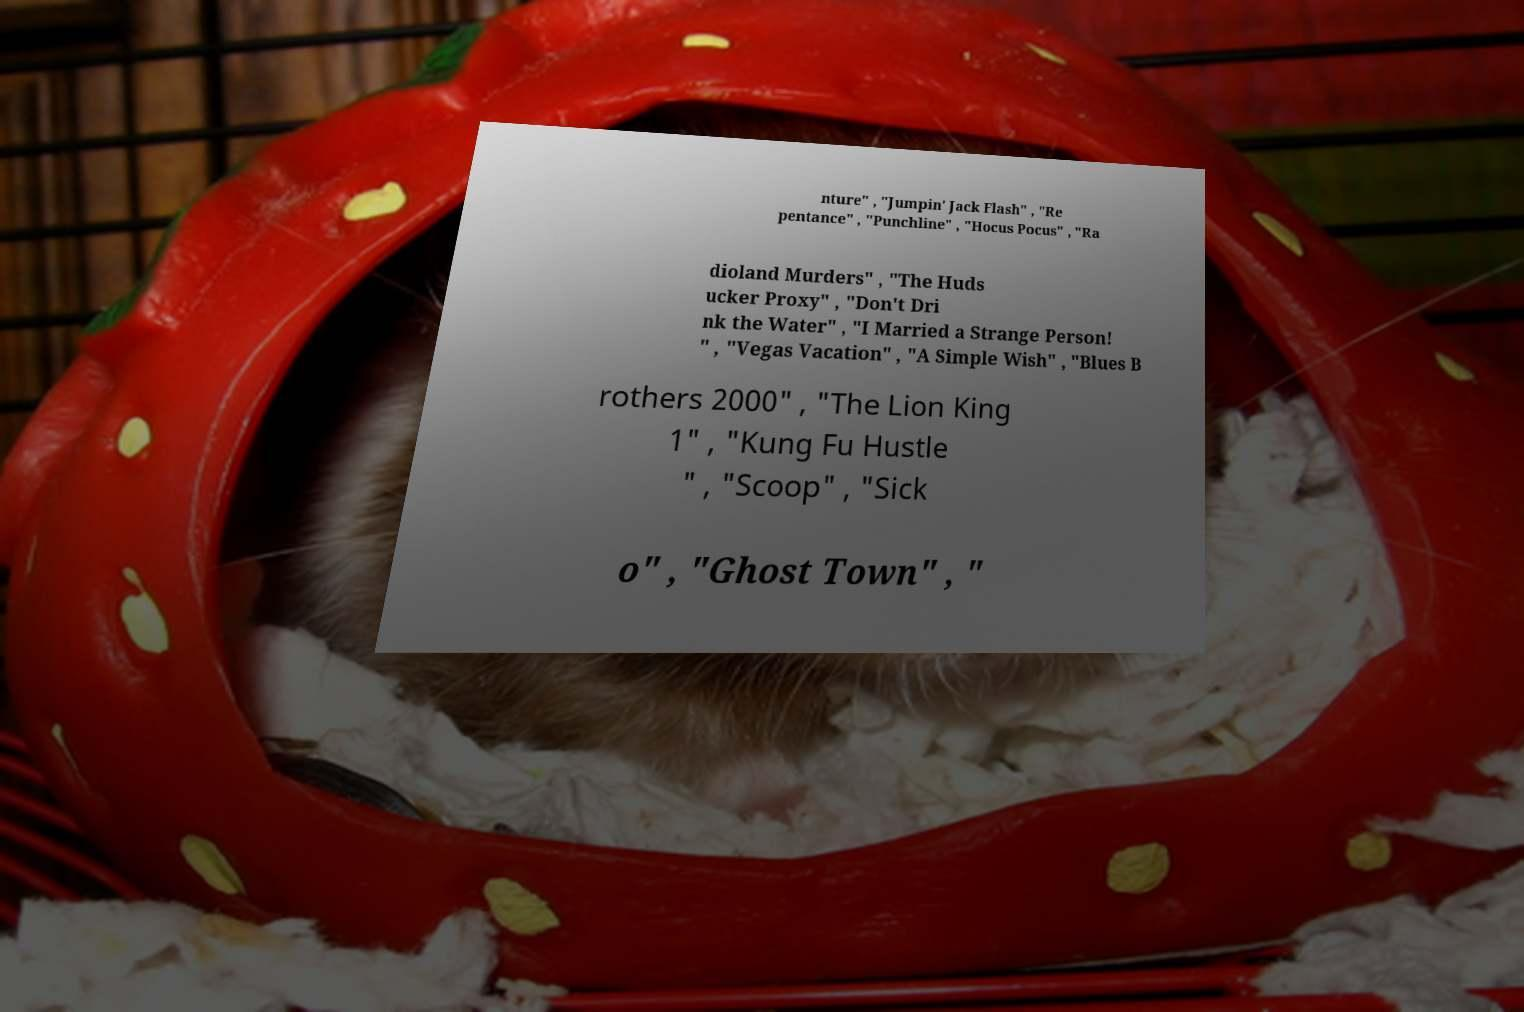Can you read and provide the text displayed in the image?This photo seems to have some interesting text. Can you extract and type it out for me? nture" , "Jumpin' Jack Flash" , "Re pentance" , "Punchline" , "Hocus Pocus" , "Ra dioland Murders" , "The Huds ucker Proxy" , "Don't Dri nk the Water" , "I Married a Strange Person! " , "Vegas Vacation" , "A Simple Wish" , "Blues B rothers 2000" , "The Lion King 1" , "Kung Fu Hustle " , "Scoop" , "Sick o" , "Ghost Town" , " 